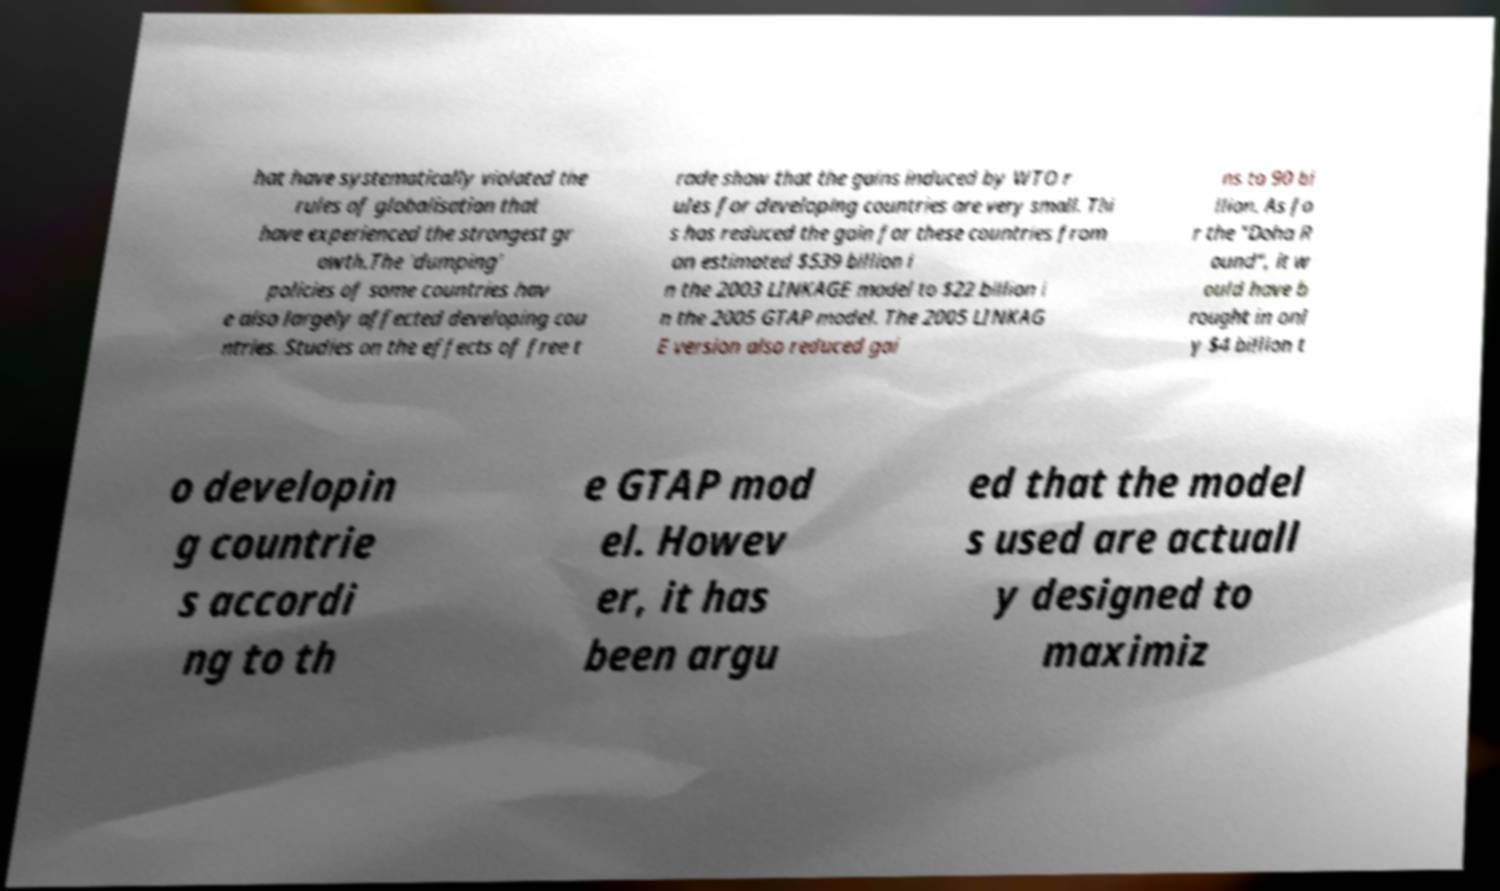Can you read and provide the text displayed in the image?This photo seems to have some interesting text. Can you extract and type it out for me? hat have systematically violated the rules of globalisation that have experienced the strongest gr owth.The 'dumping' policies of some countries hav e also largely affected developing cou ntries. Studies on the effects of free t rade show that the gains induced by WTO r ules for developing countries are very small. Thi s has reduced the gain for these countries from an estimated $539 billion i n the 2003 LINKAGE model to $22 billion i n the 2005 GTAP model. The 2005 LINKAG E version also reduced gai ns to 90 bi llion. As fo r the "Doha R ound", it w ould have b rought in onl y $4 billion t o developin g countrie s accordi ng to th e GTAP mod el. Howev er, it has been argu ed that the model s used are actuall y designed to maximiz 